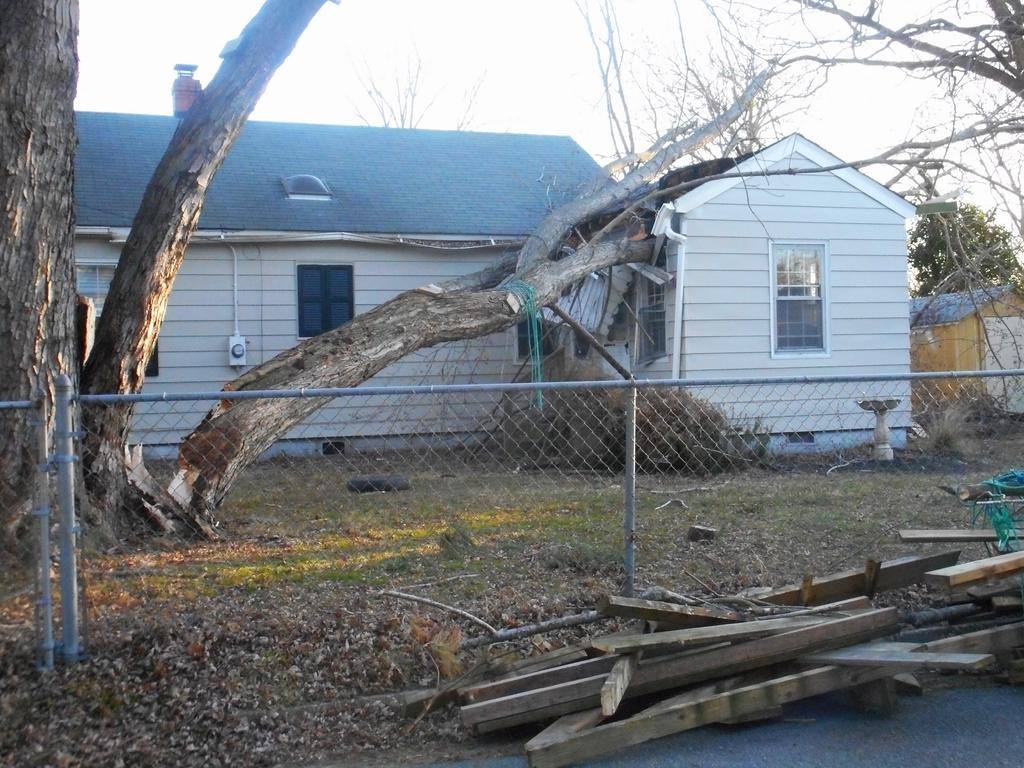What type of structure is visible in the image? There is a house in the image. What is located in front of the house? There is a tree stem and a fence in front of the house. What else can be seen in front of the house? There are wooden sticks in front of the house. What is visible at the top of the image? The sky is visible at the top of the image. How much friction is present between the wooden sticks and the ground in the image? There is no information provided about the friction between the wooden sticks and the ground in the image. --- 